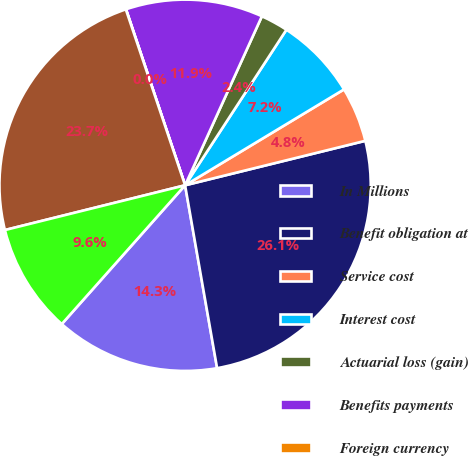<chart> <loc_0><loc_0><loc_500><loc_500><pie_chart><fcel>In Millions<fcel>Benefit obligation at<fcel>Service cost<fcel>Interest cost<fcel>Actuarial loss (gain)<fcel>Benefits payments<fcel>Foreign currency<fcel>Projected benefit obligation<fcel>Plan assets less than benefit<nl><fcel>14.32%<fcel>26.09%<fcel>4.79%<fcel>7.17%<fcel>2.4%<fcel>11.94%<fcel>0.02%<fcel>23.7%<fcel>9.56%<nl></chart> 